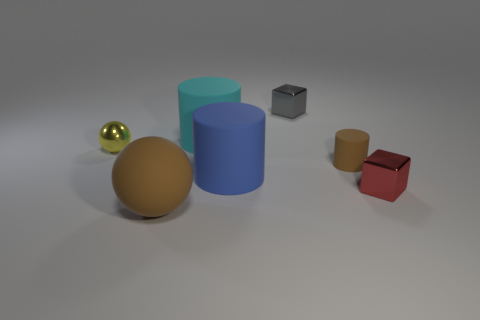Is the number of brown rubber things on the left side of the large cyan matte cylinder greater than the number of shiny things that are in front of the tiny brown matte thing?
Offer a terse response. No. What is the size of the gray cube?
Offer a terse response. Small. There is a tiny gray object that is the same material as the red block; what shape is it?
Provide a short and direct response. Cube. Is the shape of the tiny metal object to the left of the large cyan thing the same as  the big brown object?
Your response must be concise. Yes. How many objects are either yellow shiny balls or gray metal things?
Your answer should be compact. 2. There is a tiny thing that is on the left side of the tiny brown matte thing and in front of the gray object; what is it made of?
Ensure brevity in your answer.  Metal. Do the yellow sphere and the gray block have the same size?
Keep it short and to the point. Yes. There is a brown object to the left of the blue thing that is in front of the yellow sphere; what is its size?
Provide a short and direct response. Large. What number of objects are both in front of the small brown rubber object and left of the tiny brown rubber cylinder?
Offer a terse response. 2. There is a large brown matte sphere to the left of the large cylinder in front of the big cyan cylinder; is there a brown rubber object behind it?
Offer a very short reply. Yes. 